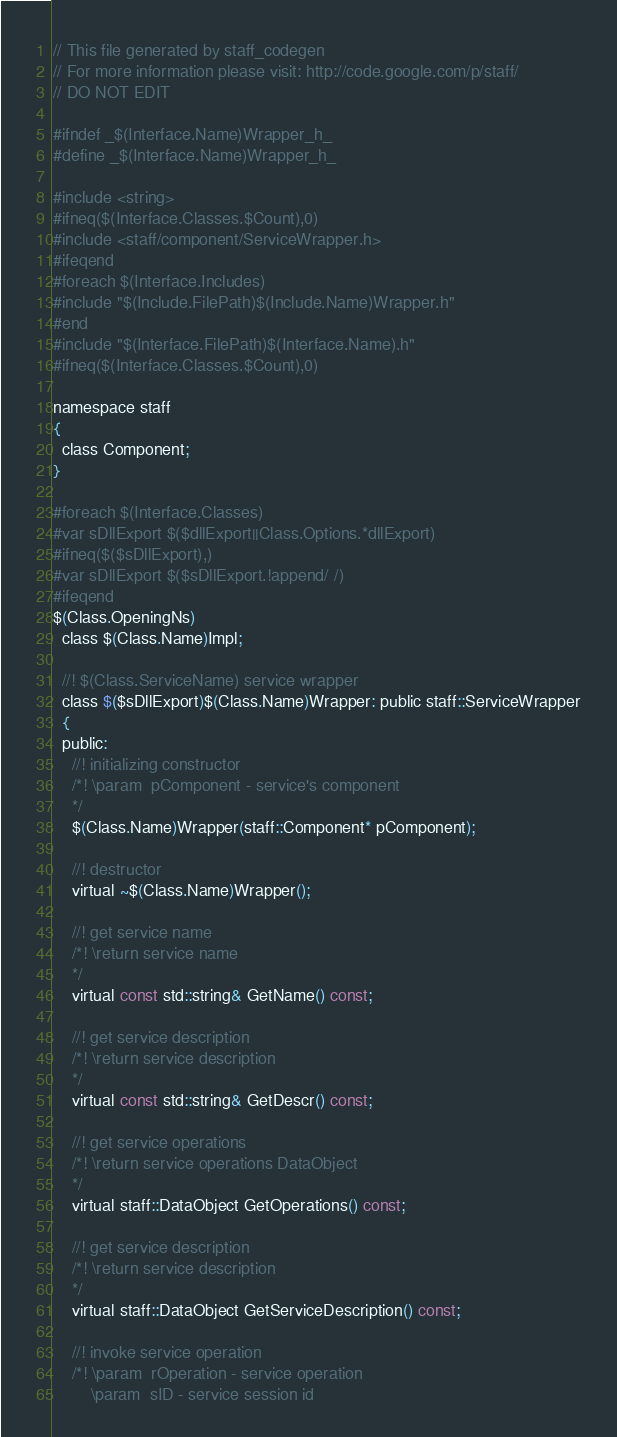Convert code to text. <code><loc_0><loc_0><loc_500><loc_500><_C_>// This file generated by staff_codegen
// For more information please visit: http://code.google.com/p/staff/
// DO NOT EDIT

#ifndef _$(Interface.Name)Wrapper_h_
#define _$(Interface.Name)Wrapper_h_

#include <string>
#ifneq($(Interface.Classes.$Count),0)
#include <staff/component/ServiceWrapper.h>
#ifeqend
#foreach $(Interface.Includes)
#include "$(Include.FilePath)$(Include.Name)Wrapper.h"
#end
#include "$(Interface.FilePath)$(Interface.Name).h"
#ifneq($(Interface.Classes.$Count),0)

namespace staff
{
  class Component;
}

#foreach $(Interface.Classes)
#var sDllExport $($dllExport||Class.Options.*dllExport)
#ifneq($($sDllExport),)
#var sDllExport $($sDllExport.!append/ /)
#ifeqend
$(Class.OpeningNs)
  class $(Class.Name)Impl;

  //! $(Class.ServiceName) service wrapper
  class $($sDllExport)$(Class.Name)Wrapper: public staff::ServiceWrapper
  {
  public:
    //! initializing constructor
    /*! \param  pComponent - service's component
    */
    $(Class.Name)Wrapper(staff::Component* pComponent);

    //! destructor
    virtual ~$(Class.Name)Wrapper();

    //! get service name
    /*! \return service name
    */
    virtual const std::string& GetName() const;

    //! get service description
    /*! \return service description
    */
    virtual const std::string& GetDescr() const;

    //! get service operations
    /*! \return service operations DataObject
    */
    virtual staff::DataObject GetOperations() const;

    //! get service description
    /*! \return service description
    */
    virtual staff::DataObject GetServiceDescription() const;

    //! invoke service operation
    /*! \param  rOperation - service operation
        \param  sID - service session id</code> 